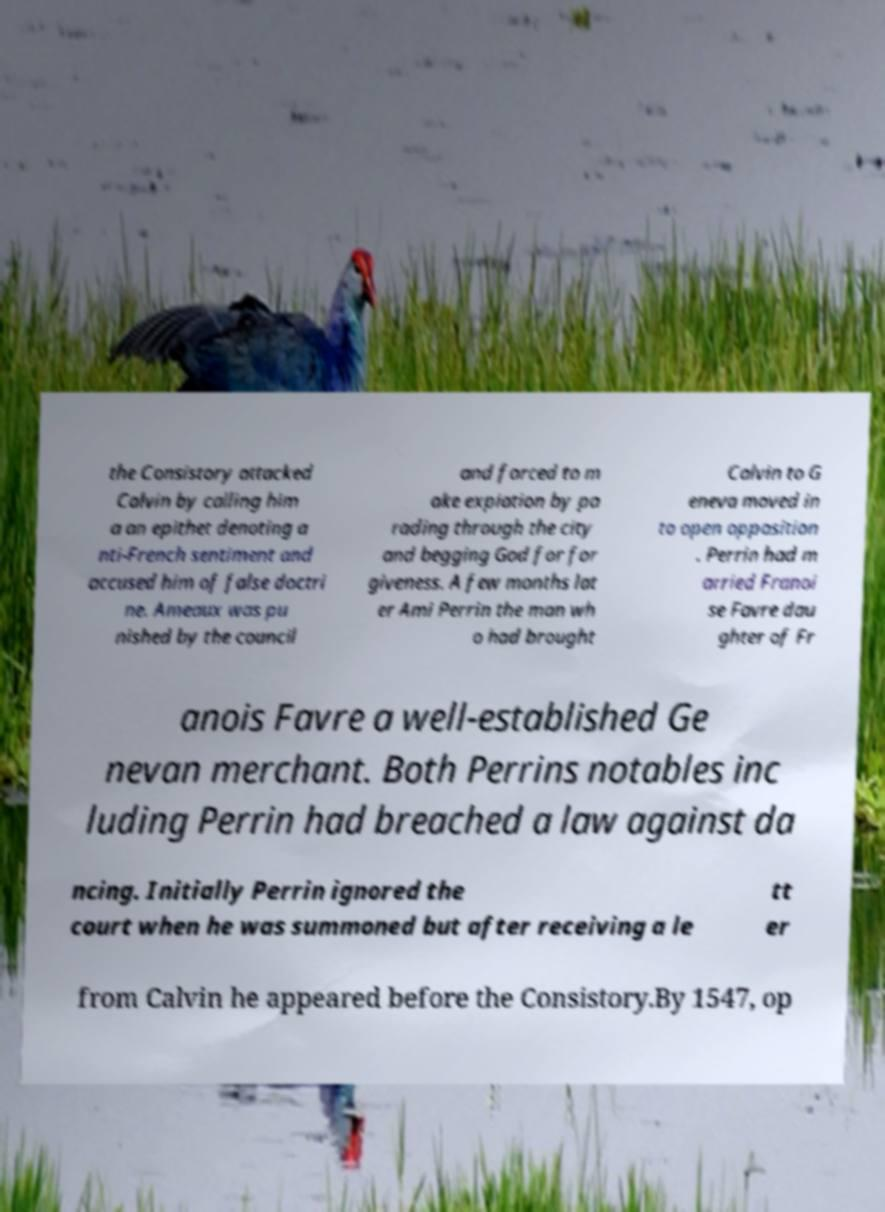Could you assist in decoding the text presented in this image and type it out clearly? the Consistory attacked Calvin by calling him a an epithet denoting a nti-French sentiment and accused him of false doctri ne. Ameaux was pu nished by the council and forced to m ake expiation by pa rading through the city and begging God for for giveness. A few months lat er Ami Perrin the man wh o had brought Calvin to G eneva moved in to open opposition . Perrin had m arried Franoi se Favre dau ghter of Fr anois Favre a well-established Ge nevan merchant. Both Perrins notables inc luding Perrin had breached a law against da ncing. Initially Perrin ignored the court when he was summoned but after receiving a le tt er from Calvin he appeared before the Consistory.By 1547, op 